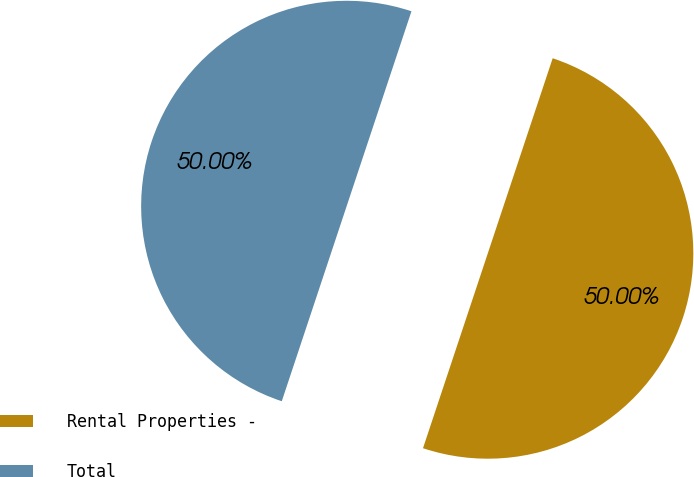<chart> <loc_0><loc_0><loc_500><loc_500><pie_chart><fcel>Rental Properties -<fcel>Total<nl><fcel>50.0%<fcel>50.0%<nl></chart> 